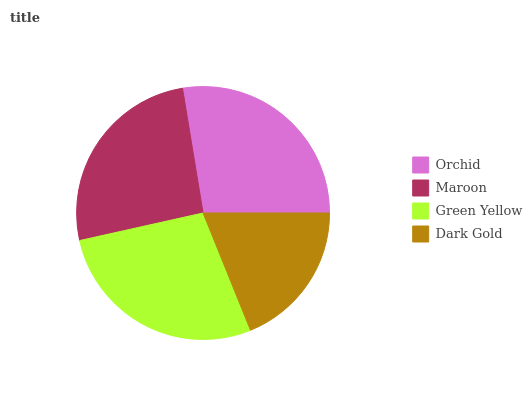Is Dark Gold the minimum?
Answer yes or no. Yes. Is Green Yellow the maximum?
Answer yes or no. Yes. Is Maroon the minimum?
Answer yes or no. No. Is Maroon the maximum?
Answer yes or no. No. Is Orchid greater than Maroon?
Answer yes or no. Yes. Is Maroon less than Orchid?
Answer yes or no. Yes. Is Maroon greater than Orchid?
Answer yes or no. No. Is Orchid less than Maroon?
Answer yes or no. No. Is Orchid the high median?
Answer yes or no. Yes. Is Maroon the low median?
Answer yes or no. Yes. Is Dark Gold the high median?
Answer yes or no. No. Is Orchid the low median?
Answer yes or no. No. 